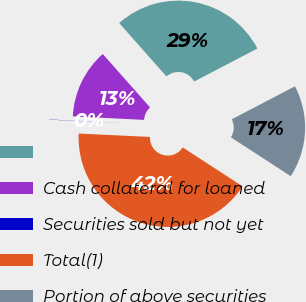<chart> <loc_0><loc_0><loc_500><loc_500><pie_chart><ecel><fcel>Cash collateral for loaned<fcel>Securities sold but not yet<fcel>Total(1)<fcel>Portion of above securities<nl><fcel>28.88%<fcel>12.67%<fcel>0.04%<fcel>41.59%<fcel>16.82%<nl></chart> 